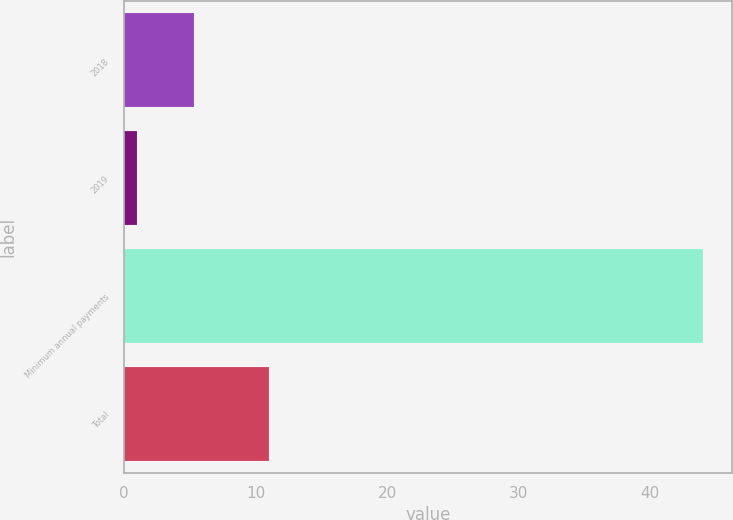Convert chart. <chart><loc_0><loc_0><loc_500><loc_500><bar_chart><fcel>2018<fcel>2019<fcel>Minimum annual payments<fcel>Total<nl><fcel>5.3<fcel>1<fcel>44<fcel>11<nl></chart> 